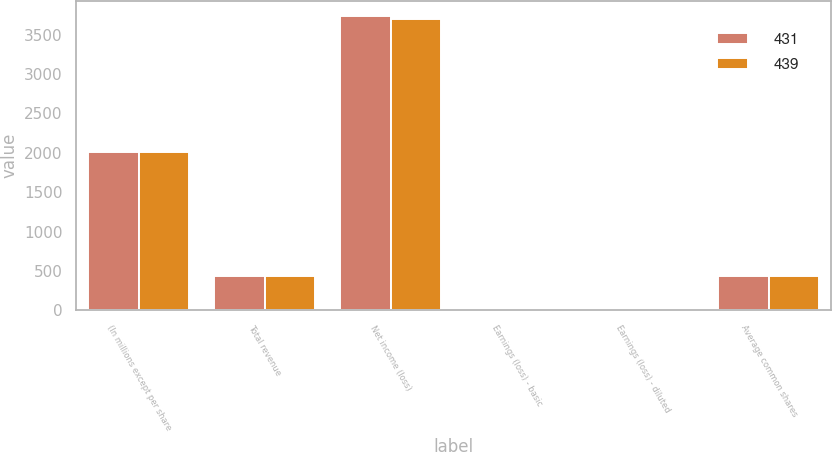Convert chart. <chart><loc_0><loc_0><loc_500><loc_500><stacked_bar_chart><ecel><fcel>(In millions except per share<fcel>Total revenue<fcel>Net income (loss)<fcel>Earnings (loss) - basic<fcel>Earnings (loss) - diluted<fcel>Average common shares<nl><fcel>431<fcel>2008<fcel>435<fcel>3742<fcel>9.58<fcel>9.6<fcel>439<nl><fcel>439<fcel>2007<fcel>435<fcel>3695<fcel>7.66<fcel>7.55<fcel>431<nl></chart> 